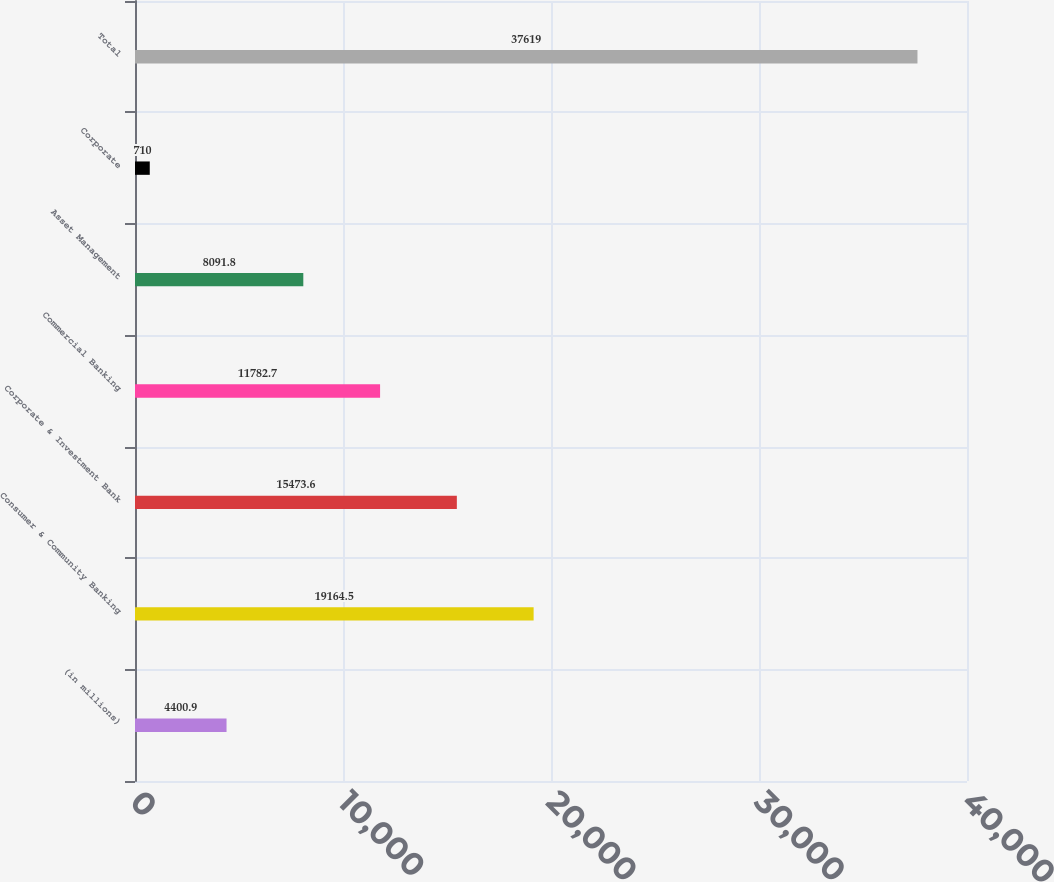Convert chart to OTSL. <chart><loc_0><loc_0><loc_500><loc_500><bar_chart><fcel>(in millions)<fcel>Consumer & Community Banking<fcel>Corporate & Investment Bank<fcel>Commercial Banking<fcel>Asset Management<fcel>Corporate<fcel>Total<nl><fcel>4400.9<fcel>19164.5<fcel>15473.6<fcel>11782.7<fcel>8091.8<fcel>710<fcel>37619<nl></chart> 